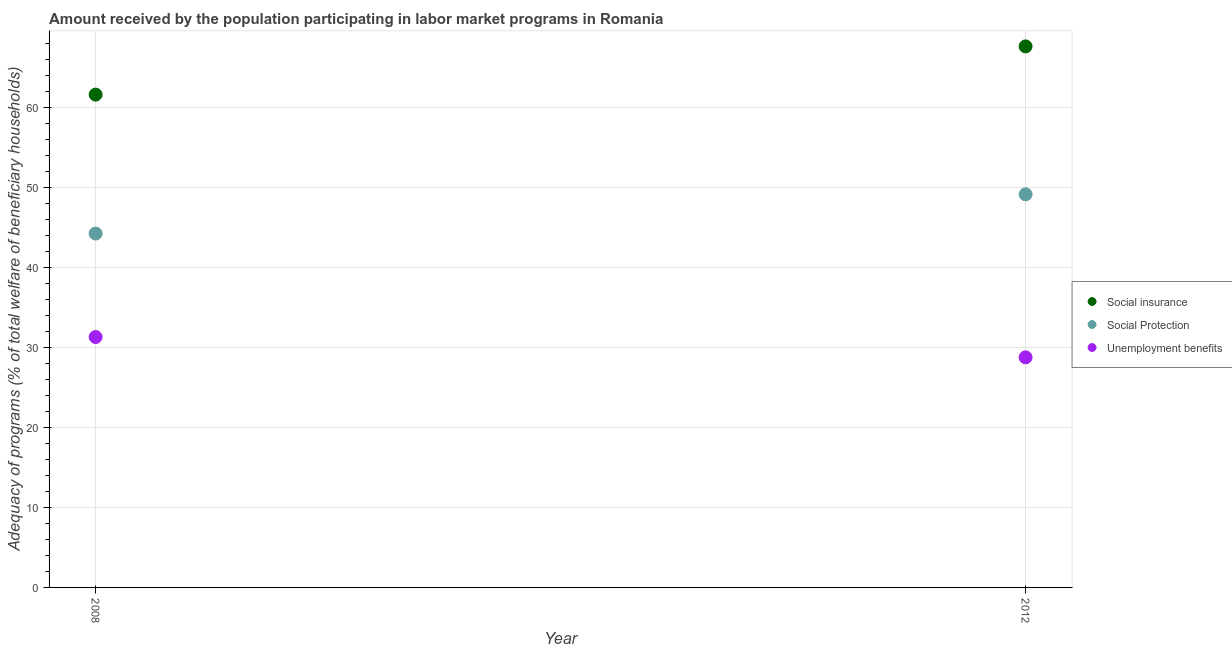What is the amount received by the population participating in unemployment benefits programs in 2012?
Your answer should be compact. 28.79. Across all years, what is the maximum amount received by the population participating in social protection programs?
Give a very brief answer. 49.18. Across all years, what is the minimum amount received by the population participating in unemployment benefits programs?
Keep it short and to the point. 28.79. In which year was the amount received by the population participating in social insurance programs maximum?
Ensure brevity in your answer.  2012. In which year was the amount received by the population participating in unemployment benefits programs minimum?
Provide a short and direct response. 2012. What is the total amount received by the population participating in social protection programs in the graph?
Your response must be concise. 93.46. What is the difference between the amount received by the population participating in unemployment benefits programs in 2008 and that in 2012?
Offer a very short reply. 2.54. What is the difference between the amount received by the population participating in social insurance programs in 2012 and the amount received by the population participating in unemployment benefits programs in 2008?
Your answer should be compact. 36.37. What is the average amount received by the population participating in unemployment benefits programs per year?
Offer a terse response. 30.06. In the year 2008, what is the difference between the amount received by the population participating in social insurance programs and amount received by the population participating in unemployment benefits programs?
Your answer should be very brief. 30.33. What is the ratio of the amount received by the population participating in social insurance programs in 2008 to that in 2012?
Keep it short and to the point. 0.91. Is it the case that in every year, the sum of the amount received by the population participating in social insurance programs and amount received by the population participating in social protection programs is greater than the amount received by the population participating in unemployment benefits programs?
Provide a succinct answer. Yes. Does the amount received by the population participating in unemployment benefits programs monotonically increase over the years?
Your answer should be very brief. No. Is the amount received by the population participating in social insurance programs strictly greater than the amount received by the population participating in social protection programs over the years?
Offer a terse response. Yes. Is the amount received by the population participating in social protection programs strictly less than the amount received by the population participating in unemployment benefits programs over the years?
Your response must be concise. No. How many years are there in the graph?
Provide a short and direct response. 2. What is the difference between two consecutive major ticks on the Y-axis?
Give a very brief answer. 10. Are the values on the major ticks of Y-axis written in scientific E-notation?
Offer a very short reply. No. Does the graph contain any zero values?
Make the answer very short. No. How are the legend labels stacked?
Provide a succinct answer. Vertical. What is the title of the graph?
Your answer should be very brief. Amount received by the population participating in labor market programs in Romania. What is the label or title of the X-axis?
Provide a short and direct response. Year. What is the label or title of the Y-axis?
Your response must be concise. Adequacy of programs (% of total welfare of beneficiary households). What is the Adequacy of programs (% of total welfare of beneficiary households) in Social insurance in 2008?
Provide a short and direct response. 61.66. What is the Adequacy of programs (% of total welfare of beneficiary households) of Social Protection in 2008?
Provide a short and direct response. 44.28. What is the Adequacy of programs (% of total welfare of beneficiary households) of Unemployment benefits in 2008?
Give a very brief answer. 31.33. What is the Adequacy of programs (% of total welfare of beneficiary households) of Social insurance in 2012?
Ensure brevity in your answer.  67.7. What is the Adequacy of programs (% of total welfare of beneficiary households) of Social Protection in 2012?
Make the answer very short. 49.18. What is the Adequacy of programs (% of total welfare of beneficiary households) in Unemployment benefits in 2012?
Offer a terse response. 28.79. Across all years, what is the maximum Adequacy of programs (% of total welfare of beneficiary households) in Social insurance?
Your answer should be compact. 67.7. Across all years, what is the maximum Adequacy of programs (% of total welfare of beneficiary households) in Social Protection?
Give a very brief answer. 49.18. Across all years, what is the maximum Adequacy of programs (% of total welfare of beneficiary households) in Unemployment benefits?
Offer a very short reply. 31.33. Across all years, what is the minimum Adequacy of programs (% of total welfare of beneficiary households) in Social insurance?
Keep it short and to the point. 61.66. Across all years, what is the minimum Adequacy of programs (% of total welfare of beneficiary households) in Social Protection?
Your answer should be very brief. 44.28. Across all years, what is the minimum Adequacy of programs (% of total welfare of beneficiary households) in Unemployment benefits?
Your response must be concise. 28.79. What is the total Adequacy of programs (% of total welfare of beneficiary households) in Social insurance in the graph?
Ensure brevity in your answer.  129.36. What is the total Adequacy of programs (% of total welfare of beneficiary households) of Social Protection in the graph?
Your answer should be compact. 93.46. What is the total Adequacy of programs (% of total welfare of beneficiary households) of Unemployment benefits in the graph?
Offer a very short reply. 60.12. What is the difference between the Adequacy of programs (% of total welfare of beneficiary households) of Social insurance in 2008 and that in 2012?
Offer a terse response. -6.04. What is the difference between the Adequacy of programs (% of total welfare of beneficiary households) of Social Protection in 2008 and that in 2012?
Your answer should be compact. -4.91. What is the difference between the Adequacy of programs (% of total welfare of beneficiary households) in Unemployment benefits in 2008 and that in 2012?
Your response must be concise. 2.54. What is the difference between the Adequacy of programs (% of total welfare of beneficiary households) in Social insurance in 2008 and the Adequacy of programs (% of total welfare of beneficiary households) in Social Protection in 2012?
Keep it short and to the point. 12.48. What is the difference between the Adequacy of programs (% of total welfare of beneficiary households) of Social insurance in 2008 and the Adequacy of programs (% of total welfare of beneficiary households) of Unemployment benefits in 2012?
Ensure brevity in your answer.  32.87. What is the difference between the Adequacy of programs (% of total welfare of beneficiary households) of Social Protection in 2008 and the Adequacy of programs (% of total welfare of beneficiary households) of Unemployment benefits in 2012?
Keep it short and to the point. 15.49. What is the average Adequacy of programs (% of total welfare of beneficiary households) in Social insurance per year?
Keep it short and to the point. 64.68. What is the average Adequacy of programs (% of total welfare of beneficiary households) in Social Protection per year?
Keep it short and to the point. 46.73. What is the average Adequacy of programs (% of total welfare of beneficiary households) of Unemployment benefits per year?
Your response must be concise. 30.06. In the year 2008, what is the difference between the Adequacy of programs (% of total welfare of beneficiary households) of Social insurance and Adequacy of programs (% of total welfare of beneficiary households) of Social Protection?
Your response must be concise. 17.38. In the year 2008, what is the difference between the Adequacy of programs (% of total welfare of beneficiary households) in Social insurance and Adequacy of programs (% of total welfare of beneficiary households) in Unemployment benefits?
Your answer should be very brief. 30.33. In the year 2008, what is the difference between the Adequacy of programs (% of total welfare of beneficiary households) in Social Protection and Adequacy of programs (% of total welfare of beneficiary households) in Unemployment benefits?
Make the answer very short. 12.95. In the year 2012, what is the difference between the Adequacy of programs (% of total welfare of beneficiary households) in Social insurance and Adequacy of programs (% of total welfare of beneficiary households) in Social Protection?
Ensure brevity in your answer.  18.51. In the year 2012, what is the difference between the Adequacy of programs (% of total welfare of beneficiary households) of Social insurance and Adequacy of programs (% of total welfare of beneficiary households) of Unemployment benefits?
Your response must be concise. 38.91. In the year 2012, what is the difference between the Adequacy of programs (% of total welfare of beneficiary households) in Social Protection and Adequacy of programs (% of total welfare of beneficiary households) in Unemployment benefits?
Provide a short and direct response. 20.4. What is the ratio of the Adequacy of programs (% of total welfare of beneficiary households) in Social insurance in 2008 to that in 2012?
Offer a terse response. 0.91. What is the ratio of the Adequacy of programs (% of total welfare of beneficiary households) in Social Protection in 2008 to that in 2012?
Make the answer very short. 0.9. What is the ratio of the Adequacy of programs (% of total welfare of beneficiary households) in Unemployment benefits in 2008 to that in 2012?
Provide a succinct answer. 1.09. What is the difference between the highest and the second highest Adequacy of programs (% of total welfare of beneficiary households) in Social insurance?
Give a very brief answer. 6.04. What is the difference between the highest and the second highest Adequacy of programs (% of total welfare of beneficiary households) in Social Protection?
Ensure brevity in your answer.  4.91. What is the difference between the highest and the second highest Adequacy of programs (% of total welfare of beneficiary households) of Unemployment benefits?
Keep it short and to the point. 2.54. What is the difference between the highest and the lowest Adequacy of programs (% of total welfare of beneficiary households) of Social insurance?
Keep it short and to the point. 6.04. What is the difference between the highest and the lowest Adequacy of programs (% of total welfare of beneficiary households) in Social Protection?
Ensure brevity in your answer.  4.91. What is the difference between the highest and the lowest Adequacy of programs (% of total welfare of beneficiary households) in Unemployment benefits?
Provide a short and direct response. 2.54. 